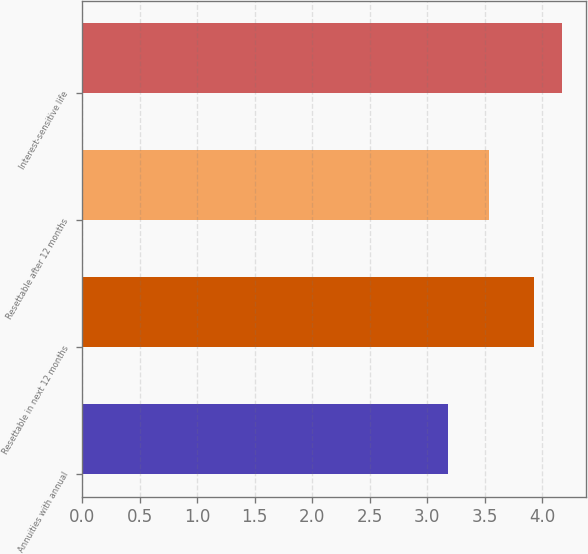<chart> <loc_0><loc_0><loc_500><loc_500><bar_chart><fcel>Annuities with annual<fcel>Resettable in next 12 months<fcel>Resettable after 12 months<fcel>Interest-sensitive life<nl><fcel>3.18<fcel>3.93<fcel>3.54<fcel>4.17<nl></chart> 